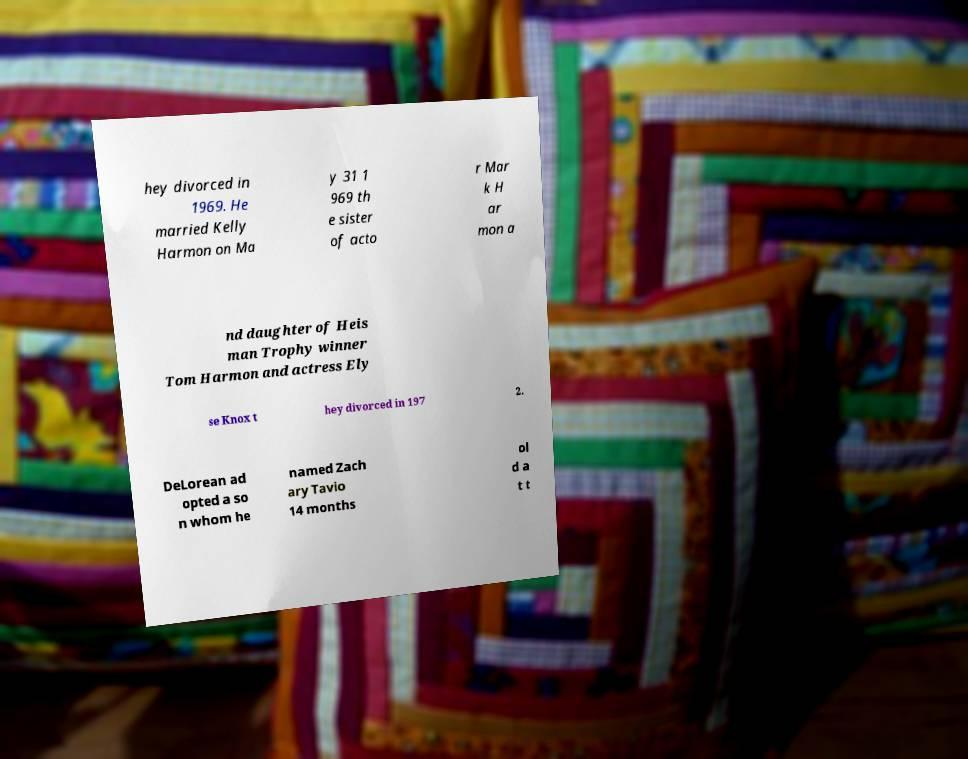I need the written content from this picture converted into text. Can you do that? hey divorced in 1969. He married Kelly Harmon on Ma y 31 1 969 th e sister of acto r Mar k H ar mon a nd daughter of Heis man Trophy winner Tom Harmon and actress Ely se Knox t hey divorced in 197 2. DeLorean ad opted a so n whom he named Zach ary Tavio 14 months ol d a t t 